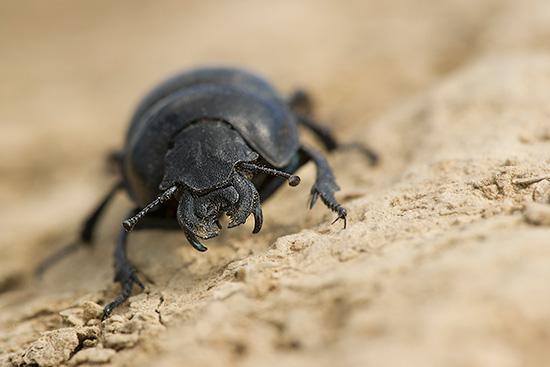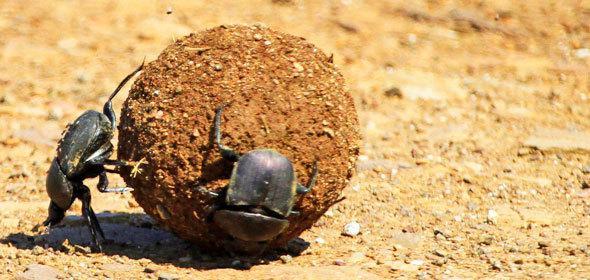The first image is the image on the left, the second image is the image on the right. For the images displayed, is the sentence "There are two bugs in one of the images." factually correct? Answer yes or no. Yes. 